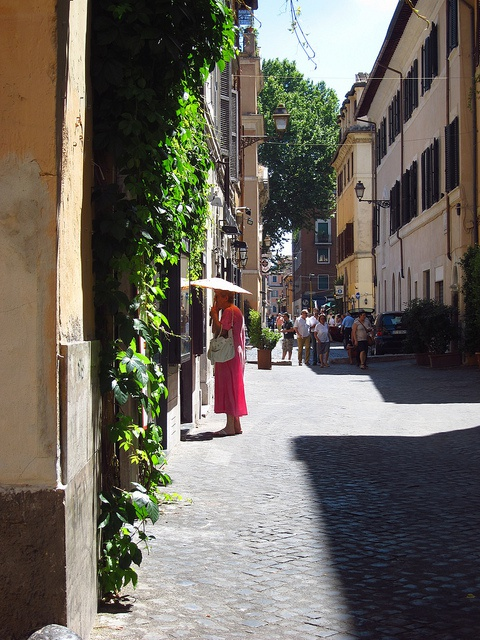Describe the objects in this image and their specific colors. I can see people in maroon, gray, and brown tones, car in maroon, black, gray, navy, and blue tones, handbag in maroon, gray, and black tones, people in maroon, black, gray, and brown tones, and people in maroon, gray, and black tones in this image. 